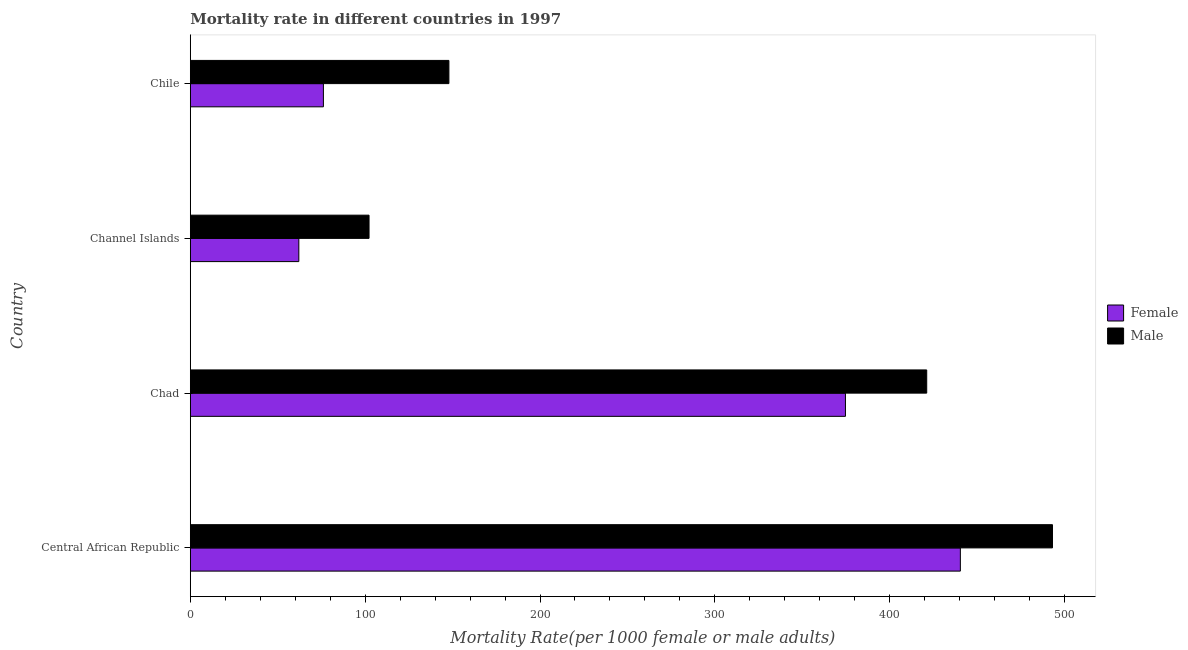How many groups of bars are there?
Ensure brevity in your answer.  4. Are the number of bars on each tick of the Y-axis equal?
Provide a short and direct response. Yes. What is the label of the 3rd group of bars from the top?
Offer a terse response. Chad. What is the male mortality rate in Central African Republic?
Make the answer very short. 493.07. Across all countries, what is the maximum female mortality rate?
Offer a terse response. 440.39. Across all countries, what is the minimum female mortality rate?
Give a very brief answer. 62.07. In which country was the female mortality rate maximum?
Your response must be concise. Central African Republic. In which country was the female mortality rate minimum?
Your answer should be very brief. Channel Islands. What is the total male mortality rate in the graph?
Provide a succinct answer. 1164.35. What is the difference between the female mortality rate in Chad and that in Channel Islands?
Offer a terse response. 312.61. What is the difference between the male mortality rate in Central African Republic and the female mortality rate in Channel Islands?
Offer a very short reply. 431. What is the average male mortality rate per country?
Your response must be concise. 291.09. What is the difference between the female mortality rate and male mortality rate in Channel Islands?
Offer a very short reply. -40.15. In how many countries, is the male mortality rate greater than 440 ?
Your answer should be compact. 1. What is the ratio of the female mortality rate in Channel Islands to that in Chile?
Provide a succinct answer. 0.81. Is the male mortality rate in Central African Republic less than that in Chile?
Offer a terse response. No. What is the difference between the highest and the second highest female mortality rate?
Provide a succinct answer. 65.71. What is the difference between the highest and the lowest male mortality rate?
Give a very brief answer. 390.85. Is the sum of the male mortality rate in Central African Republic and Channel Islands greater than the maximum female mortality rate across all countries?
Provide a succinct answer. Yes. What does the 2nd bar from the bottom in Chile represents?
Provide a succinct answer. Male. Are the values on the major ticks of X-axis written in scientific E-notation?
Your answer should be very brief. No. Does the graph contain any zero values?
Offer a terse response. No. Does the graph contain grids?
Provide a short and direct response. No. Where does the legend appear in the graph?
Keep it short and to the point. Center right. How many legend labels are there?
Keep it short and to the point. 2. What is the title of the graph?
Give a very brief answer. Mortality rate in different countries in 1997. Does "Nonresident" appear as one of the legend labels in the graph?
Ensure brevity in your answer.  No. What is the label or title of the X-axis?
Offer a terse response. Mortality Rate(per 1000 female or male adults). What is the label or title of the Y-axis?
Provide a succinct answer. Country. What is the Mortality Rate(per 1000 female or male adults) of Female in Central African Republic?
Your response must be concise. 440.39. What is the Mortality Rate(per 1000 female or male adults) in Male in Central African Republic?
Make the answer very short. 493.07. What is the Mortality Rate(per 1000 female or male adults) of Female in Chad?
Provide a short and direct response. 374.68. What is the Mortality Rate(per 1000 female or male adults) in Male in Chad?
Offer a terse response. 421.15. What is the Mortality Rate(per 1000 female or male adults) of Female in Channel Islands?
Make the answer very short. 62.07. What is the Mortality Rate(per 1000 female or male adults) in Male in Channel Islands?
Keep it short and to the point. 102.22. What is the Mortality Rate(per 1000 female or male adults) in Female in Chile?
Offer a terse response. 76.13. What is the Mortality Rate(per 1000 female or male adults) in Male in Chile?
Provide a short and direct response. 147.9. Across all countries, what is the maximum Mortality Rate(per 1000 female or male adults) in Female?
Offer a very short reply. 440.39. Across all countries, what is the maximum Mortality Rate(per 1000 female or male adults) of Male?
Make the answer very short. 493.07. Across all countries, what is the minimum Mortality Rate(per 1000 female or male adults) of Female?
Offer a terse response. 62.07. Across all countries, what is the minimum Mortality Rate(per 1000 female or male adults) in Male?
Your answer should be very brief. 102.22. What is the total Mortality Rate(per 1000 female or male adults) of Female in the graph?
Provide a short and direct response. 953.27. What is the total Mortality Rate(per 1000 female or male adults) of Male in the graph?
Offer a terse response. 1164.35. What is the difference between the Mortality Rate(per 1000 female or male adults) in Female in Central African Republic and that in Chad?
Your response must be concise. 65.71. What is the difference between the Mortality Rate(per 1000 female or male adults) in Male in Central African Republic and that in Chad?
Your answer should be very brief. 71.92. What is the difference between the Mortality Rate(per 1000 female or male adults) in Female in Central African Republic and that in Channel Islands?
Provide a succinct answer. 378.32. What is the difference between the Mortality Rate(per 1000 female or male adults) in Male in Central African Republic and that in Channel Islands?
Your response must be concise. 390.85. What is the difference between the Mortality Rate(per 1000 female or male adults) of Female in Central African Republic and that in Chile?
Offer a terse response. 364.26. What is the difference between the Mortality Rate(per 1000 female or male adults) in Male in Central African Republic and that in Chile?
Offer a very short reply. 345.18. What is the difference between the Mortality Rate(per 1000 female or male adults) of Female in Chad and that in Channel Islands?
Offer a very short reply. 312.61. What is the difference between the Mortality Rate(per 1000 female or male adults) of Male in Chad and that in Channel Islands?
Keep it short and to the point. 318.93. What is the difference between the Mortality Rate(per 1000 female or male adults) in Female in Chad and that in Chile?
Ensure brevity in your answer.  298.55. What is the difference between the Mortality Rate(per 1000 female or male adults) in Male in Chad and that in Chile?
Make the answer very short. 273.26. What is the difference between the Mortality Rate(per 1000 female or male adults) of Female in Channel Islands and that in Chile?
Give a very brief answer. -14.05. What is the difference between the Mortality Rate(per 1000 female or male adults) in Male in Channel Islands and that in Chile?
Make the answer very short. -45.67. What is the difference between the Mortality Rate(per 1000 female or male adults) in Female in Central African Republic and the Mortality Rate(per 1000 female or male adults) in Male in Chad?
Provide a short and direct response. 19.23. What is the difference between the Mortality Rate(per 1000 female or male adults) of Female in Central African Republic and the Mortality Rate(per 1000 female or male adults) of Male in Channel Islands?
Offer a very short reply. 338.17. What is the difference between the Mortality Rate(per 1000 female or male adults) of Female in Central African Republic and the Mortality Rate(per 1000 female or male adults) of Male in Chile?
Give a very brief answer. 292.49. What is the difference between the Mortality Rate(per 1000 female or male adults) of Female in Chad and the Mortality Rate(per 1000 female or male adults) of Male in Channel Islands?
Ensure brevity in your answer.  272.46. What is the difference between the Mortality Rate(per 1000 female or male adults) of Female in Chad and the Mortality Rate(per 1000 female or male adults) of Male in Chile?
Make the answer very short. 226.78. What is the difference between the Mortality Rate(per 1000 female or male adults) in Female in Channel Islands and the Mortality Rate(per 1000 female or male adults) in Male in Chile?
Give a very brief answer. -85.83. What is the average Mortality Rate(per 1000 female or male adults) of Female per country?
Make the answer very short. 238.32. What is the average Mortality Rate(per 1000 female or male adults) of Male per country?
Your response must be concise. 291.09. What is the difference between the Mortality Rate(per 1000 female or male adults) of Female and Mortality Rate(per 1000 female or male adults) of Male in Central African Republic?
Your answer should be compact. -52.69. What is the difference between the Mortality Rate(per 1000 female or male adults) in Female and Mortality Rate(per 1000 female or male adults) in Male in Chad?
Provide a short and direct response. -46.47. What is the difference between the Mortality Rate(per 1000 female or male adults) in Female and Mortality Rate(per 1000 female or male adults) in Male in Channel Islands?
Provide a short and direct response. -40.15. What is the difference between the Mortality Rate(per 1000 female or male adults) in Female and Mortality Rate(per 1000 female or male adults) in Male in Chile?
Provide a short and direct response. -71.77. What is the ratio of the Mortality Rate(per 1000 female or male adults) in Female in Central African Republic to that in Chad?
Your response must be concise. 1.18. What is the ratio of the Mortality Rate(per 1000 female or male adults) of Male in Central African Republic to that in Chad?
Provide a short and direct response. 1.17. What is the ratio of the Mortality Rate(per 1000 female or male adults) in Female in Central African Republic to that in Channel Islands?
Make the answer very short. 7.09. What is the ratio of the Mortality Rate(per 1000 female or male adults) of Male in Central African Republic to that in Channel Islands?
Ensure brevity in your answer.  4.82. What is the ratio of the Mortality Rate(per 1000 female or male adults) in Female in Central African Republic to that in Chile?
Offer a very short reply. 5.78. What is the ratio of the Mortality Rate(per 1000 female or male adults) in Male in Central African Republic to that in Chile?
Your answer should be very brief. 3.33. What is the ratio of the Mortality Rate(per 1000 female or male adults) in Female in Chad to that in Channel Islands?
Provide a short and direct response. 6.04. What is the ratio of the Mortality Rate(per 1000 female or male adults) in Male in Chad to that in Channel Islands?
Keep it short and to the point. 4.12. What is the ratio of the Mortality Rate(per 1000 female or male adults) in Female in Chad to that in Chile?
Offer a very short reply. 4.92. What is the ratio of the Mortality Rate(per 1000 female or male adults) in Male in Chad to that in Chile?
Your answer should be compact. 2.85. What is the ratio of the Mortality Rate(per 1000 female or male adults) in Female in Channel Islands to that in Chile?
Give a very brief answer. 0.82. What is the ratio of the Mortality Rate(per 1000 female or male adults) in Male in Channel Islands to that in Chile?
Provide a succinct answer. 0.69. What is the difference between the highest and the second highest Mortality Rate(per 1000 female or male adults) of Female?
Provide a succinct answer. 65.71. What is the difference between the highest and the second highest Mortality Rate(per 1000 female or male adults) of Male?
Keep it short and to the point. 71.92. What is the difference between the highest and the lowest Mortality Rate(per 1000 female or male adults) in Female?
Ensure brevity in your answer.  378.32. What is the difference between the highest and the lowest Mortality Rate(per 1000 female or male adults) in Male?
Provide a succinct answer. 390.85. 